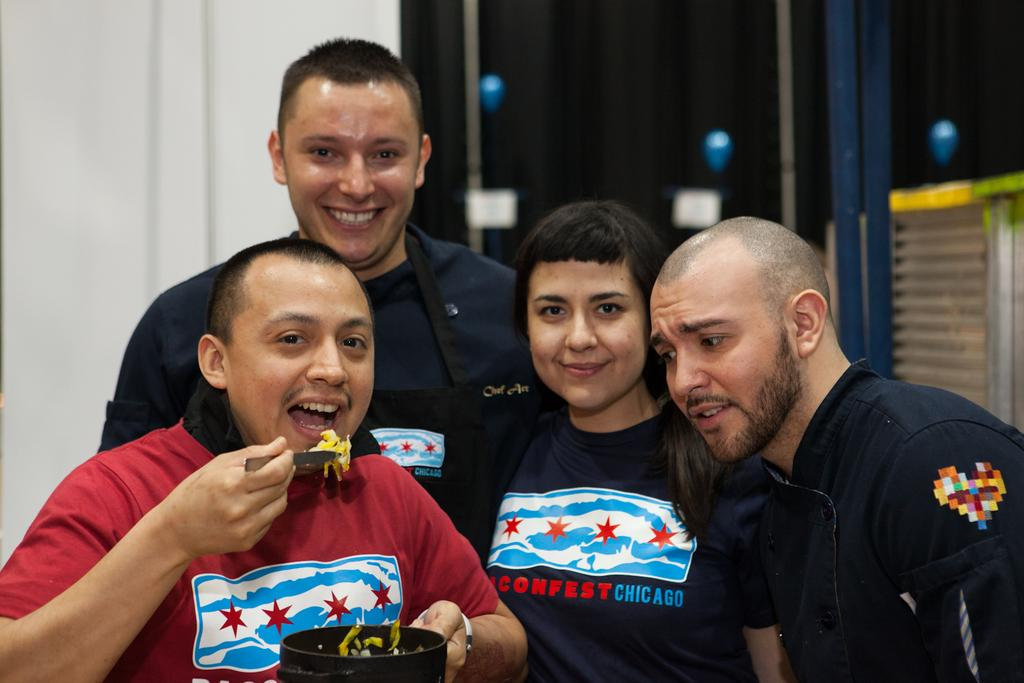How many people are present in the image? There are four people in the image. What is one person on the left doing? One person on the left is holding a bowl and a spoon. What is in the bowl that the person is holding? There is a food item in the bowl. What can be seen in the background of the image? There is a wall in the background of the image. How is the wall depicted in the image? The wall is blurred. What type of toad can be seen sitting on the food item in the bowl? There is no toad present in the image; the bowl contains a food item. What type of waste is visible in the image? There is no waste visible in the image; it features four people and a bowl with a food item. 